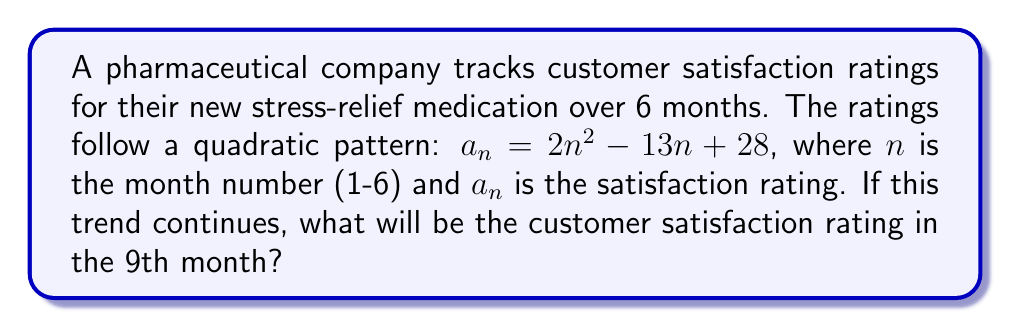Give your solution to this math problem. To solve this problem, we need to follow these steps:

1. Understand the given quadratic pattern:
   $a_n = 2n^2 - 13n + 28$, where $n$ is the month number

2. We need to find the satisfaction rating for the 9th month, so we'll substitute $n = 9$ into the equation:

   $a_9 = 2(9)^2 - 13(9) + 28$

3. Let's calculate step by step:
   $a_9 = 2(81) - 13(9) + 28$
   $a_9 = 162 - 117 + 28$

4. Now, we simply perform the arithmetic:
   $a_9 = 162 - 117 + 28 = 73$

Therefore, if the trend continues, the customer satisfaction rating in the 9th month will be 73.
Answer: 73 